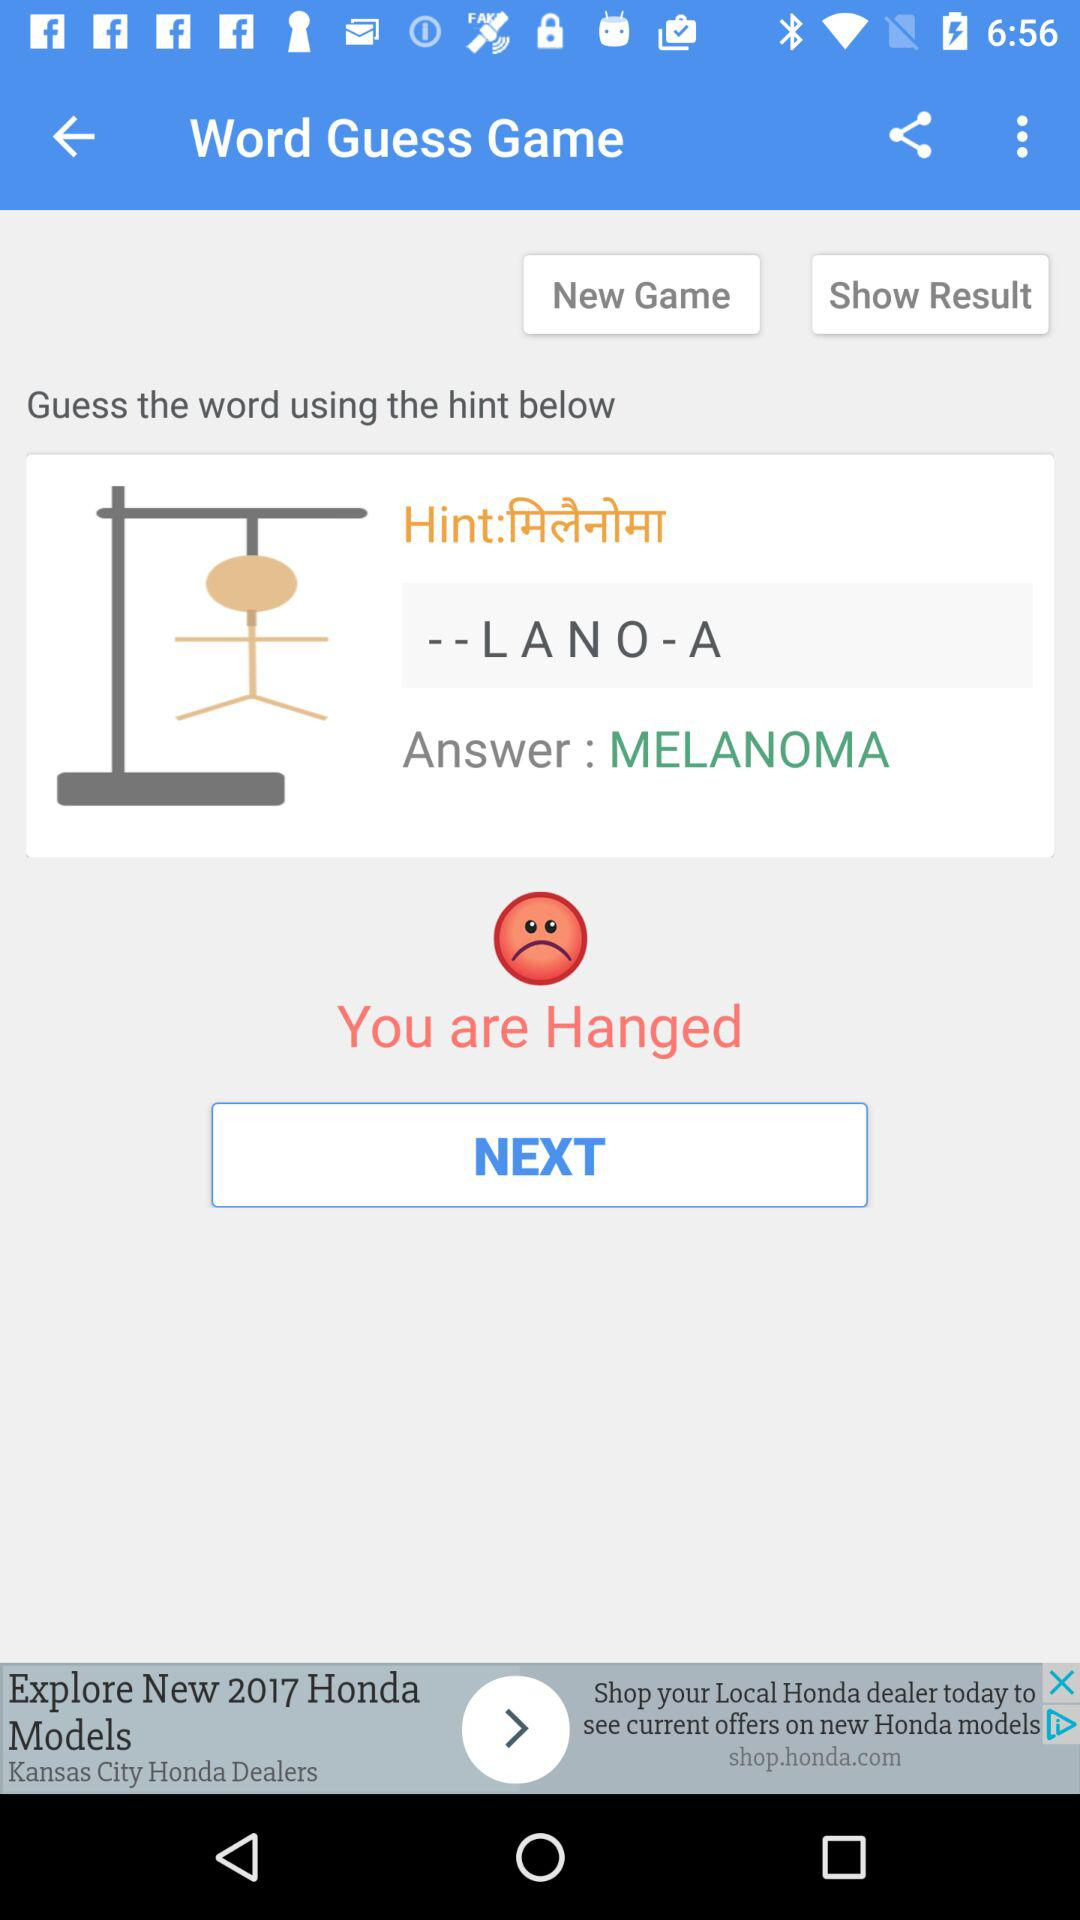How many chances left does the user have?
Answer the question using a single word or phrase. 2 